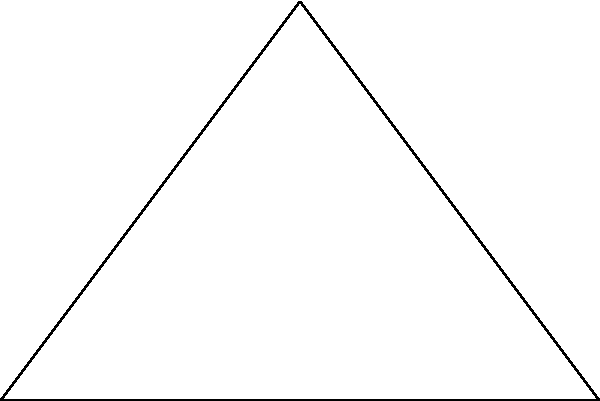A non-profit organization focused on healthcare reform is planning to build its new headquarters on a triangular plot of land. The plot has a base length of 6 units and a height of 4 units. What is the area of this triangular plot in square units? To find the area of a triangle, we can use the formula:

$$A = \frac{1}{2} \times base \times height$$

Given:
- Base length = 6 units
- Height = 4 units

Step 1: Substitute the values into the formula.
$$A = \frac{1}{2} \times 6 \times 4$$

Step 2: Multiply the numbers.
$$A = \frac{1}{2} \times 24$$

Step 3: Calculate the final result.
$$A = 12$$

Therefore, the area of the triangular plot is 12 square units.
Answer: 12 square units 